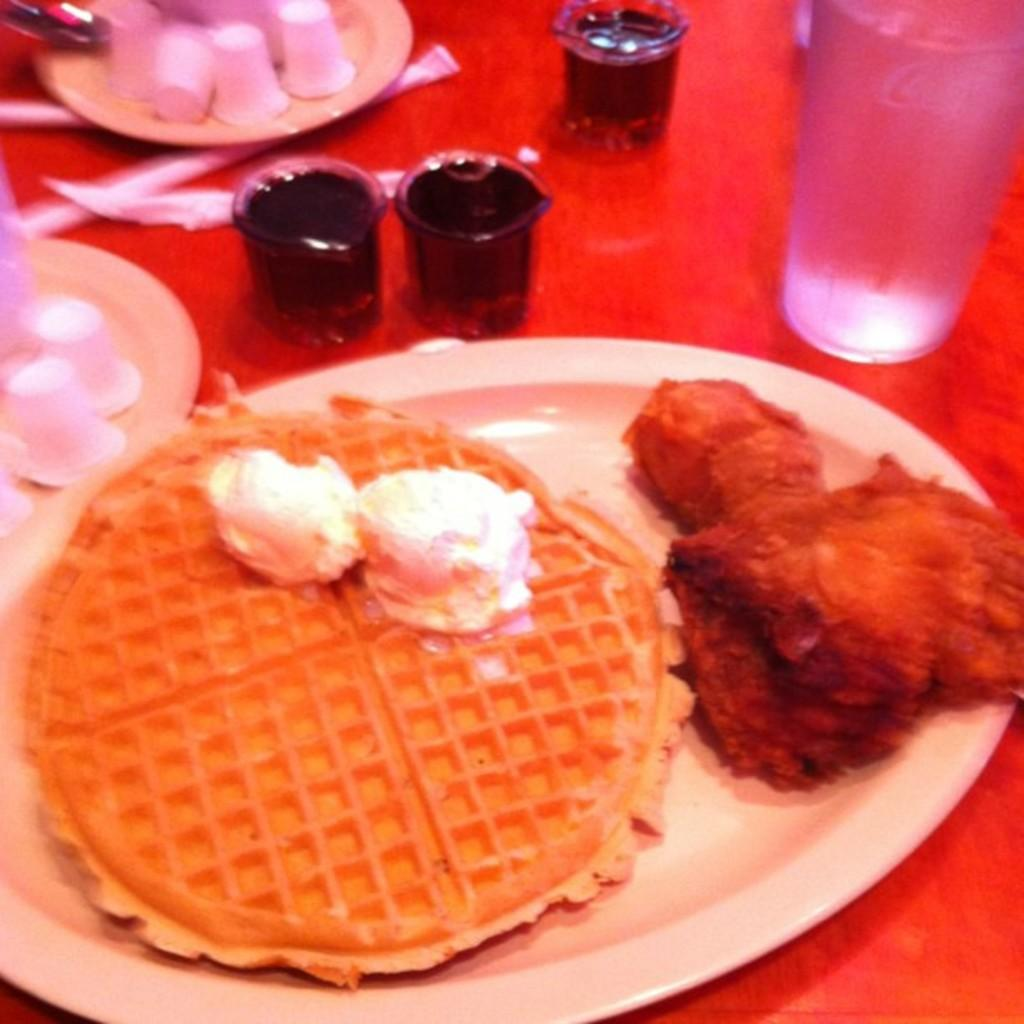What is on the plate in the image? There are food items on a plate in the image. Where are the glasses located in the image? The glasses are on a table in the image. What type of respect can be seen in the image? There is no indication of respect in the image, as it features food items on a plate and glasses on a table. How many chickens are visible in the image? There are no chickens present in the image. 